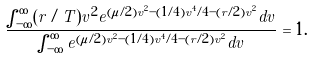<formula> <loc_0><loc_0><loc_500><loc_500>\frac { \int _ { - \infty } ^ { \infty } ( r / T ) v ^ { 2 } e ^ { ( \mu / 2 ) v ^ { 2 } - ( 1 / 4 ) v ^ { 4 } / 4 - ( r / 2 ) v ^ { 2 } } d v } { \int _ { - \infty } ^ { \infty } e ^ { ( \mu / 2 ) v ^ { 2 } - ( 1 / 4 ) v ^ { 4 } / 4 - ( r / 2 ) v ^ { 2 } } d v } = 1 .</formula> 